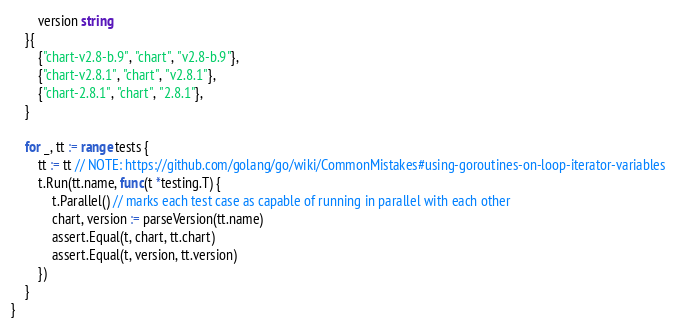<code> <loc_0><loc_0><loc_500><loc_500><_Go_>		version string
	}{
		{"chart-v2.8-b.9", "chart", "v2.8-b.9"},
		{"chart-v2.8.1", "chart", "v2.8.1"},
		{"chart-2.8.1", "chart", "2.8.1"},
	}

	for _, tt := range tests {
		tt := tt // NOTE: https://github.com/golang/go/wiki/CommonMistakes#using-goroutines-on-loop-iterator-variables
		t.Run(tt.name, func(t *testing.T) {
			t.Parallel() // marks each test case as capable of running in parallel with each other
			chart, version := parseVersion(tt.name)
			assert.Equal(t, chart, tt.chart)
			assert.Equal(t, version, tt.version)
		})
	}
}
</code> 